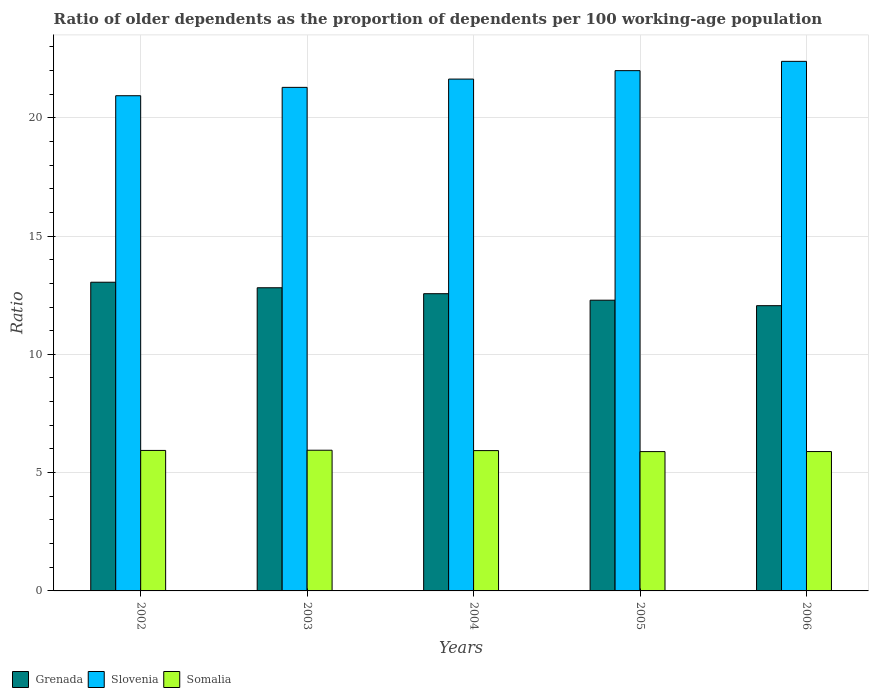Are the number of bars per tick equal to the number of legend labels?
Offer a terse response. Yes. Are the number of bars on each tick of the X-axis equal?
Your answer should be very brief. Yes. How many bars are there on the 2nd tick from the left?
Your response must be concise. 3. What is the age dependency ratio(old) in Somalia in 2005?
Keep it short and to the point. 5.89. Across all years, what is the maximum age dependency ratio(old) in Somalia?
Ensure brevity in your answer.  5.95. Across all years, what is the minimum age dependency ratio(old) in Grenada?
Provide a short and direct response. 12.06. In which year was the age dependency ratio(old) in Grenada minimum?
Offer a very short reply. 2006. What is the total age dependency ratio(old) in Somalia in the graph?
Give a very brief answer. 29.6. What is the difference between the age dependency ratio(old) in Grenada in 2002 and that in 2003?
Offer a very short reply. 0.23. What is the difference between the age dependency ratio(old) in Somalia in 2006 and the age dependency ratio(old) in Slovenia in 2004?
Offer a terse response. -15.74. What is the average age dependency ratio(old) in Grenada per year?
Give a very brief answer. 12.55. In the year 2005, what is the difference between the age dependency ratio(old) in Grenada and age dependency ratio(old) in Somalia?
Your response must be concise. 6.4. What is the ratio of the age dependency ratio(old) in Somalia in 2003 to that in 2006?
Offer a very short reply. 1.01. Is the age dependency ratio(old) in Somalia in 2003 less than that in 2004?
Give a very brief answer. No. Is the difference between the age dependency ratio(old) in Grenada in 2002 and 2003 greater than the difference between the age dependency ratio(old) in Somalia in 2002 and 2003?
Make the answer very short. Yes. What is the difference between the highest and the second highest age dependency ratio(old) in Slovenia?
Provide a short and direct response. 0.39. What is the difference between the highest and the lowest age dependency ratio(old) in Grenada?
Make the answer very short. 0.99. In how many years, is the age dependency ratio(old) in Slovenia greater than the average age dependency ratio(old) in Slovenia taken over all years?
Offer a terse response. 2. What does the 2nd bar from the left in 2003 represents?
Give a very brief answer. Slovenia. What does the 2nd bar from the right in 2005 represents?
Give a very brief answer. Slovenia. Does the graph contain any zero values?
Make the answer very short. No. Where does the legend appear in the graph?
Keep it short and to the point. Bottom left. How are the legend labels stacked?
Your answer should be very brief. Horizontal. What is the title of the graph?
Offer a very short reply. Ratio of older dependents as the proportion of dependents per 100 working-age population. What is the label or title of the Y-axis?
Provide a short and direct response. Ratio. What is the Ratio in Grenada in 2002?
Make the answer very short. 13.05. What is the Ratio of Slovenia in 2002?
Make the answer very short. 20.93. What is the Ratio in Somalia in 2002?
Your answer should be compact. 5.94. What is the Ratio in Grenada in 2003?
Make the answer very short. 12.81. What is the Ratio in Slovenia in 2003?
Make the answer very short. 21.28. What is the Ratio of Somalia in 2003?
Your response must be concise. 5.95. What is the Ratio in Grenada in 2004?
Keep it short and to the point. 12.56. What is the Ratio of Slovenia in 2004?
Provide a short and direct response. 21.63. What is the Ratio in Somalia in 2004?
Keep it short and to the point. 5.93. What is the Ratio of Grenada in 2005?
Provide a succinct answer. 12.29. What is the Ratio in Slovenia in 2005?
Give a very brief answer. 21.99. What is the Ratio of Somalia in 2005?
Provide a short and direct response. 5.89. What is the Ratio in Grenada in 2006?
Keep it short and to the point. 12.06. What is the Ratio in Slovenia in 2006?
Give a very brief answer. 22.38. What is the Ratio in Somalia in 2006?
Ensure brevity in your answer.  5.89. Across all years, what is the maximum Ratio in Grenada?
Provide a short and direct response. 13.05. Across all years, what is the maximum Ratio of Slovenia?
Keep it short and to the point. 22.38. Across all years, what is the maximum Ratio of Somalia?
Provide a succinct answer. 5.95. Across all years, what is the minimum Ratio of Grenada?
Offer a very short reply. 12.06. Across all years, what is the minimum Ratio in Slovenia?
Provide a succinct answer. 20.93. Across all years, what is the minimum Ratio of Somalia?
Your answer should be very brief. 5.89. What is the total Ratio of Grenada in the graph?
Ensure brevity in your answer.  62.77. What is the total Ratio in Slovenia in the graph?
Keep it short and to the point. 108.22. What is the total Ratio of Somalia in the graph?
Make the answer very short. 29.6. What is the difference between the Ratio of Grenada in 2002 and that in 2003?
Make the answer very short. 0.23. What is the difference between the Ratio in Slovenia in 2002 and that in 2003?
Provide a succinct answer. -0.35. What is the difference between the Ratio of Somalia in 2002 and that in 2003?
Your answer should be very brief. -0.01. What is the difference between the Ratio of Grenada in 2002 and that in 2004?
Give a very brief answer. 0.48. What is the difference between the Ratio of Slovenia in 2002 and that in 2004?
Offer a very short reply. -0.7. What is the difference between the Ratio in Somalia in 2002 and that in 2004?
Provide a succinct answer. 0.01. What is the difference between the Ratio in Grenada in 2002 and that in 2005?
Make the answer very short. 0.76. What is the difference between the Ratio of Slovenia in 2002 and that in 2005?
Provide a succinct answer. -1.06. What is the difference between the Ratio in Somalia in 2002 and that in 2005?
Offer a very short reply. 0.05. What is the difference between the Ratio in Slovenia in 2002 and that in 2006?
Offer a very short reply. -1.45. What is the difference between the Ratio of Somalia in 2002 and that in 2006?
Offer a terse response. 0.05. What is the difference between the Ratio of Grenada in 2003 and that in 2004?
Offer a terse response. 0.25. What is the difference between the Ratio of Slovenia in 2003 and that in 2004?
Your answer should be very brief. -0.35. What is the difference between the Ratio of Somalia in 2003 and that in 2004?
Ensure brevity in your answer.  0.02. What is the difference between the Ratio of Grenada in 2003 and that in 2005?
Give a very brief answer. 0.53. What is the difference between the Ratio of Slovenia in 2003 and that in 2005?
Offer a terse response. -0.71. What is the difference between the Ratio in Somalia in 2003 and that in 2005?
Keep it short and to the point. 0.06. What is the difference between the Ratio in Grenada in 2003 and that in 2006?
Ensure brevity in your answer.  0.76. What is the difference between the Ratio in Slovenia in 2003 and that in 2006?
Your answer should be very brief. -1.1. What is the difference between the Ratio in Somalia in 2003 and that in 2006?
Give a very brief answer. 0.06. What is the difference between the Ratio in Grenada in 2004 and that in 2005?
Provide a succinct answer. 0.27. What is the difference between the Ratio in Slovenia in 2004 and that in 2005?
Ensure brevity in your answer.  -0.36. What is the difference between the Ratio of Somalia in 2004 and that in 2005?
Your response must be concise. 0.04. What is the difference between the Ratio of Grenada in 2004 and that in 2006?
Provide a succinct answer. 0.51. What is the difference between the Ratio of Slovenia in 2004 and that in 2006?
Offer a terse response. -0.75. What is the difference between the Ratio in Somalia in 2004 and that in 2006?
Provide a succinct answer. 0.04. What is the difference between the Ratio of Grenada in 2005 and that in 2006?
Your response must be concise. 0.23. What is the difference between the Ratio in Slovenia in 2005 and that in 2006?
Provide a short and direct response. -0.39. What is the difference between the Ratio in Somalia in 2005 and that in 2006?
Make the answer very short. -0. What is the difference between the Ratio of Grenada in 2002 and the Ratio of Slovenia in 2003?
Make the answer very short. -8.24. What is the difference between the Ratio in Grenada in 2002 and the Ratio in Somalia in 2003?
Offer a very short reply. 7.1. What is the difference between the Ratio of Slovenia in 2002 and the Ratio of Somalia in 2003?
Provide a short and direct response. 14.98. What is the difference between the Ratio in Grenada in 2002 and the Ratio in Slovenia in 2004?
Your response must be concise. -8.59. What is the difference between the Ratio in Grenada in 2002 and the Ratio in Somalia in 2004?
Offer a terse response. 7.12. What is the difference between the Ratio in Slovenia in 2002 and the Ratio in Somalia in 2004?
Your answer should be compact. 15. What is the difference between the Ratio in Grenada in 2002 and the Ratio in Slovenia in 2005?
Provide a short and direct response. -8.94. What is the difference between the Ratio of Grenada in 2002 and the Ratio of Somalia in 2005?
Your answer should be compact. 7.16. What is the difference between the Ratio in Slovenia in 2002 and the Ratio in Somalia in 2005?
Provide a short and direct response. 15.04. What is the difference between the Ratio in Grenada in 2002 and the Ratio in Slovenia in 2006?
Offer a terse response. -9.34. What is the difference between the Ratio of Grenada in 2002 and the Ratio of Somalia in 2006?
Keep it short and to the point. 7.16. What is the difference between the Ratio of Slovenia in 2002 and the Ratio of Somalia in 2006?
Offer a very short reply. 15.04. What is the difference between the Ratio of Grenada in 2003 and the Ratio of Slovenia in 2004?
Provide a short and direct response. -8.82. What is the difference between the Ratio of Grenada in 2003 and the Ratio of Somalia in 2004?
Provide a short and direct response. 6.88. What is the difference between the Ratio of Slovenia in 2003 and the Ratio of Somalia in 2004?
Make the answer very short. 15.35. What is the difference between the Ratio of Grenada in 2003 and the Ratio of Slovenia in 2005?
Provide a succinct answer. -9.18. What is the difference between the Ratio of Grenada in 2003 and the Ratio of Somalia in 2005?
Make the answer very short. 6.93. What is the difference between the Ratio of Slovenia in 2003 and the Ratio of Somalia in 2005?
Ensure brevity in your answer.  15.4. What is the difference between the Ratio of Grenada in 2003 and the Ratio of Slovenia in 2006?
Ensure brevity in your answer.  -9.57. What is the difference between the Ratio in Grenada in 2003 and the Ratio in Somalia in 2006?
Provide a succinct answer. 6.92. What is the difference between the Ratio in Slovenia in 2003 and the Ratio in Somalia in 2006?
Your answer should be very brief. 15.39. What is the difference between the Ratio of Grenada in 2004 and the Ratio of Slovenia in 2005?
Make the answer very short. -9.43. What is the difference between the Ratio of Grenada in 2004 and the Ratio of Somalia in 2005?
Make the answer very short. 6.67. What is the difference between the Ratio of Slovenia in 2004 and the Ratio of Somalia in 2005?
Provide a succinct answer. 15.75. What is the difference between the Ratio of Grenada in 2004 and the Ratio of Slovenia in 2006?
Provide a succinct answer. -9.82. What is the difference between the Ratio of Grenada in 2004 and the Ratio of Somalia in 2006?
Offer a terse response. 6.67. What is the difference between the Ratio of Slovenia in 2004 and the Ratio of Somalia in 2006?
Provide a short and direct response. 15.74. What is the difference between the Ratio of Grenada in 2005 and the Ratio of Slovenia in 2006?
Ensure brevity in your answer.  -10.1. What is the difference between the Ratio of Grenada in 2005 and the Ratio of Somalia in 2006?
Provide a short and direct response. 6.4. What is the difference between the Ratio of Slovenia in 2005 and the Ratio of Somalia in 2006?
Your answer should be very brief. 16.1. What is the average Ratio in Grenada per year?
Make the answer very short. 12.55. What is the average Ratio in Slovenia per year?
Make the answer very short. 21.64. What is the average Ratio in Somalia per year?
Make the answer very short. 5.92. In the year 2002, what is the difference between the Ratio in Grenada and Ratio in Slovenia?
Provide a short and direct response. -7.88. In the year 2002, what is the difference between the Ratio in Grenada and Ratio in Somalia?
Offer a very short reply. 7.11. In the year 2002, what is the difference between the Ratio of Slovenia and Ratio of Somalia?
Your answer should be very brief. 14.99. In the year 2003, what is the difference between the Ratio in Grenada and Ratio in Slovenia?
Ensure brevity in your answer.  -8.47. In the year 2003, what is the difference between the Ratio in Grenada and Ratio in Somalia?
Keep it short and to the point. 6.87. In the year 2003, what is the difference between the Ratio in Slovenia and Ratio in Somalia?
Offer a terse response. 15.34. In the year 2004, what is the difference between the Ratio of Grenada and Ratio of Slovenia?
Offer a very short reply. -9.07. In the year 2004, what is the difference between the Ratio of Grenada and Ratio of Somalia?
Keep it short and to the point. 6.63. In the year 2004, what is the difference between the Ratio in Slovenia and Ratio in Somalia?
Offer a very short reply. 15.7. In the year 2005, what is the difference between the Ratio of Grenada and Ratio of Slovenia?
Offer a terse response. -9.7. In the year 2005, what is the difference between the Ratio of Grenada and Ratio of Somalia?
Make the answer very short. 6.4. In the year 2005, what is the difference between the Ratio of Slovenia and Ratio of Somalia?
Your response must be concise. 16.1. In the year 2006, what is the difference between the Ratio of Grenada and Ratio of Slovenia?
Make the answer very short. -10.33. In the year 2006, what is the difference between the Ratio in Grenada and Ratio in Somalia?
Ensure brevity in your answer.  6.17. In the year 2006, what is the difference between the Ratio of Slovenia and Ratio of Somalia?
Provide a succinct answer. 16.49. What is the ratio of the Ratio in Grenada in 2002 to that in 2003?
Ensure brevity in your answer.  1.02. What is the ratio of the Ratio of Slovenia in 2002 to that in 2003?
Ensure brevity in your answer.  0.98. What is the ratio of the Ratio of Grenada in 2002 to that in 2004?
Keep it short and to the point. 1.04. What is the ratio of the Ratio in Slovenia in 2002 to that in 2004?
Make the answer very short. 0.97. What is the ratio of the Ratio in Somalia in 2002 to that in 2004?
Your answer should be compact. 1. What is the ratio of the Ratio in Grenada in 2002 to that in 2005?
Provide a succinct answer. 1.06. What is the ratio of the Ratio of Slovenia in 2002 to that in 2005?
Give a very brief answer. 0.95. What is the ratio of the Ratio in Somalia in 2002 to that in 2005?
Your answer should be very brief. 1.01. What is the ratio of the Ratio in Grenada in 2002 to that in 2006?
Keep it short and to the point. 1.08. What is the ratio of the Ratio in Slovenia in 2002 to that in 2006?
Your response must be concise. 0.94. What is the ratio of the Ratio of Slovenia in 2003 to that in 2004?
Your answer should be compact. 0.98. What is the ratio of the Ratio of Grenada in 2003 to that in 2005?
Offer a very short reply. 1.04. What is the ratio of the Ratio of Slovenia in 2003 to that in 2005?
Your response must be concise. 0.97. What is the ratio of the Ratio in Somalia in 2003 to that in 2005?
Make the answer very short. 1.01. What is the ratio of the Ratio in Grenada in 2003 to that in 2006?
Give a very brief answer. 1.06. What is the ratio of the Ratio in Slovenia in 2003 to that in 2006?
Ensure brevity in your answer.  0.95. What is the ratio of the Ratio in Somalia in 2003 to that in 2006?
Provide a short and direct response. 1.01. What is the ratio of the Ratio of Grenada in 2004 to that in 2005?
Provide a succinct answer. 1.02. What is the ratio of the Ratio in Slovenia in 2004 to that in 2005?
Ensure brevity in your answer.  0.98. What is the ratio of the Ratio of Grenada in 2004 to that in 2006?
Make the answer very short. 1.04. What is the ratio of the Ratio in Slovenia in 2004 to that in 2006?
Give a very brief answer. 0.97. What is the ratio of the Ratio in Somalia in 2004 to that in 2006?
Ensure brevity in your answer.  1.01. What is the ratio of the Ratio in Grenada in 2005 to that in 2006?
Your answer should be very brief. 1.02. What is the ratio of the Ratio in Slovenia in 2005 to that in 2006?
Offer a very short reply. 0.98. What is the ratio of the Ratio of Somalia in 2005 to that in 2006?
Provide a succinct answer. 1. What is the difference between the highest and the second highest Ratio of Grenada?
Keep it short and to the point. 0.23. What is the difference between the highest and the second highest Ratio of Slovenia?
Ensure brevity in your answer.  0.39. What is the difference between the highest and the second highest Ratio of Somalia?
Offer a terse response. 0.01. What is the difference between the highest and the lowest Ratio of Grenada?
Give a very brief answer. 0.99. What is the difference between the highest and the lowest Ratio of Slovenia?
Your response must be concise. 1.45. What is the difference between the highest and the lowest Ratio of Somalia?
Provide a succinct answer. 0.06. 